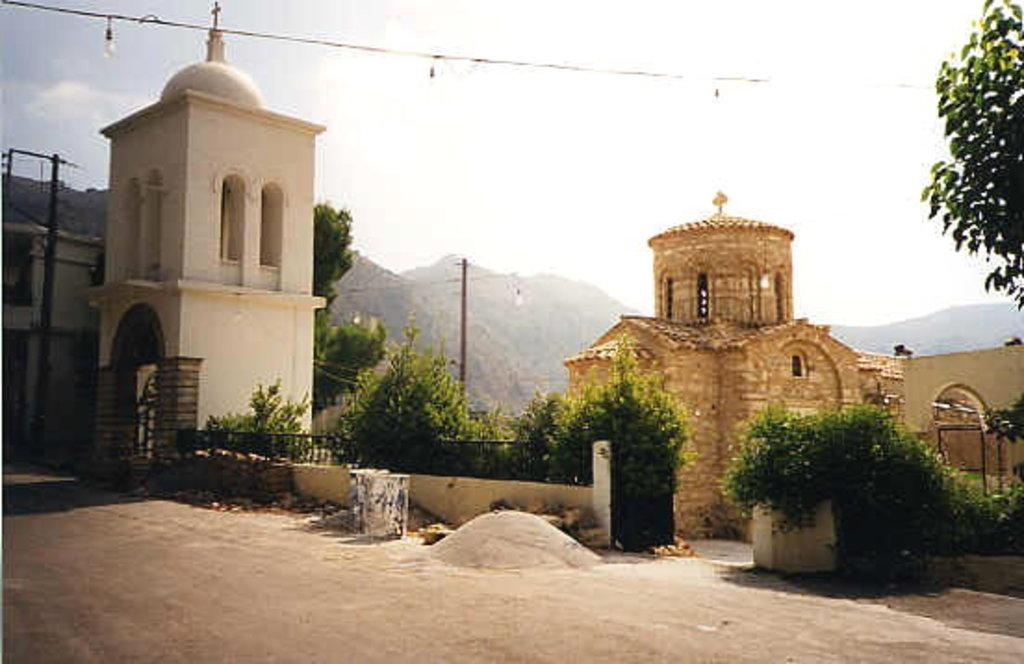What types of structures can be seen in the image? There are buildings in the image. What other elements are present in the image besides buildings? There are plants, railings, a road, a walkway, trees, poles, wires, and a few objects in the image. What can be seen in the background of the image? The background of the image includes hills and the sky. Can you tell me how many goldfish are swimming in the image? There are no goldfish present in the image. What type of wheel is visible in the image? There is no wheel visible in the image. 